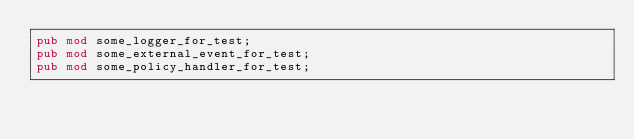Convert code to text. <code><loc_0><loc_0><loc_500><loc_500><_Rust_>pub mod some_logger_for_test;
pub mod some_external_event_for_test;
pub mod some_policy_handler_for_test;
</code> 